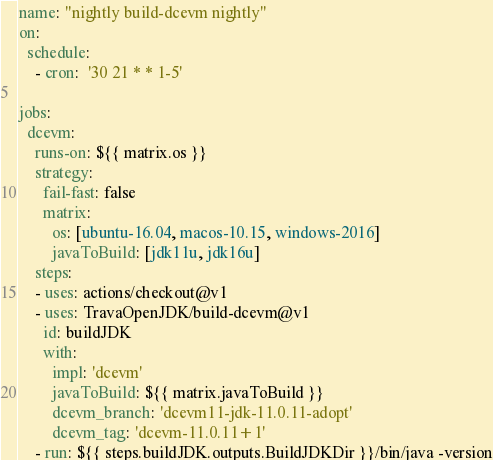Convert code to text. <code><loc_0><loc_0><loc_500><loc_500><_YAML_>name: "nightly build-dcevm nightly"
on:
  schedule:
    - cron:  '30 21 * * 1-5'

jobs:
  dcevm:
    runs-on: ${{ matrix.os }}
    strategy:
      fail-fast: false
      matrix:
        os: [ubuntu-16.04, macos-10.15, windows-2016]
        javaToBuild: [jdk11u, jdk16u]
    steps:
    - uses: actions/checkout@v1
    - uses: TravaOpenJDK/build-dcevm@v1
      id: buildJDK
      with:
        impl: 'dcevm'
        javaToBuild: ${{ matrix.javaToBuild }}
        dcevm_branch: 'dcevm11-jdk-11.0.11-adopt'
        dcevm_tag: 'dcevm-11.0.11+1'
    - run: ${{ steps.buildJDK.outputs.BuildJDKDir }}/bin/java -version
</code> 